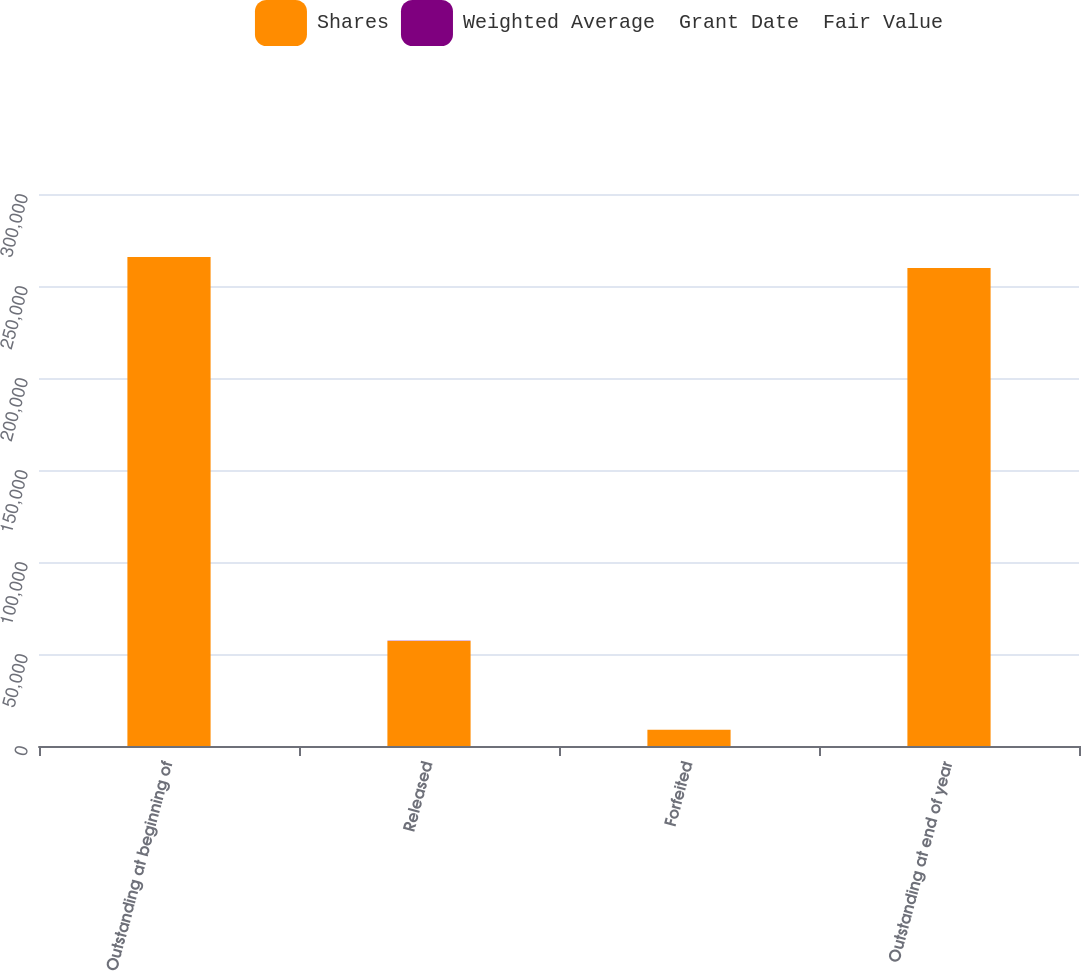Convert chart to OTSL. <chart><loc_0><loc_0><loc_500><loc_500><stacked_bar_chart><ecel><fcel>Outstanding at beginning of<fcel>Released<fcel>Forfeited<fcel>Outstanding at end of year<nl><fcel>Shares<fcel>265747<fcel>57074<fcel>8795<fcel>259727<nl><fcel>Weighted Average  Grant Date  Fair Value<fcel>77.04<fcel>107.31<fcel>81.07<fcel>86.41<nl></chart> 